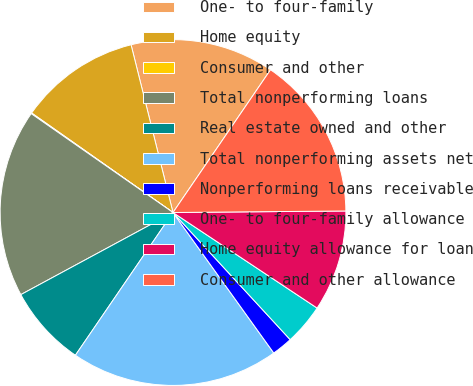Convert chart to OTSL. <chart><loc_0><loc_0><loc_500><loc_500><pie_chart><fcel>One- to four-family<fcel>Home equity<fcel>Consumer and other<fcel>Total nonperforming loans<fcel>Real estate owned and other<fcel>Total nonperforming assets net<fcel>Nonperforming loans receivable<fcel>One- to four-family allowance<fcel>Home equity allowance for loan<fcel>Consumer and other allowance<nl><fcel>13.44%<fcel>11.34%<fcel>0.07%<fcel>17.57%<fcel>7.58%<fcel>19.45%<fcel>1.95%<fcel>3.83%<fcel>9.46%<fcel>15.32%<nl></chart> 